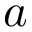<formula> <loc_0><loc_0><loc_500><loc_500>a</formula> 